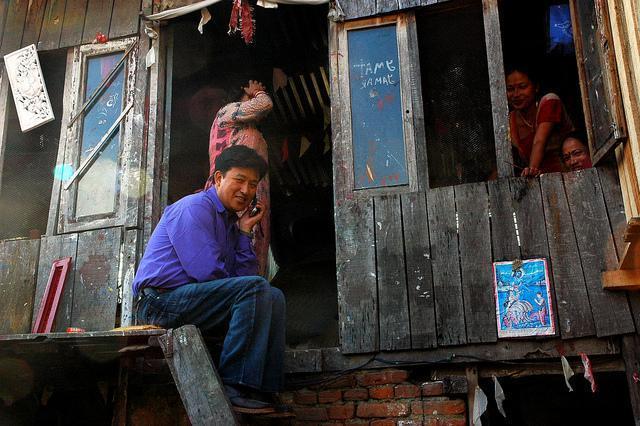How many people can you see?
Give a very brief answer. 3. 